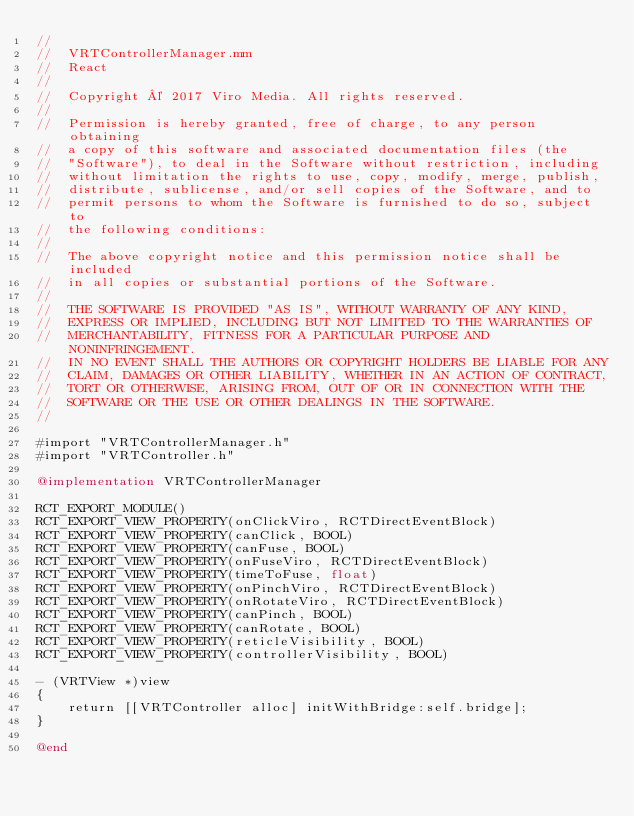<code> <loc_0><loc_0><loc_500><loc_500><_ObjectiveC_>//
//  VRTControllerManager.mm
//  React
//
//  Copyright © 2017 Viro Media. All rights reserved.
//
//  Permission is hereby granted, free of charge, to any person obtaining
//  a copy of this software and associated documentation files (the
//  "Software"), to deal in the Software without restriction, including
//  without limitation the rights to use, copy, modify, merge, publish,
//  distribute, sublicense, and/or sell copies of the Software, and to
//  permit persons to whom the Software is furnished to do so, subject to
//  the following conditions:
//
//  The above copyright notice and this permission notice shall be included
//  in all copies or substantial portions of the Software.
//
//  THE SOFTWARE IS PROVIDED "AS IS", WITHOUT WARRANTY OF ANY KIND,
//  EXPRESS OR IMPLIED, INCLUDING BUT NOT LIMITED TO THE WARRANTIES OF
//  MERCHANTABILITY, FITNESS FOR A PARTICULAR PURPOSE AND NONINFRINGEMENT.
//  IN NO EVENT SHALL THE AUTHORS OR COPYRIGHT HOLDERS BE LIABLE FOR ANY
//  CLAIM, DAMAGES OR OTHER LIABILITY, WHETHER IN AN ACTION OF CONTRACT,
//  TORT OR OTHERWISE, ARISING FROM, OUT OF OR IN CONNECTION WITH THE
//  SOFTWARE OR THE USE OR OTHER DEALINGS IN THE SOFTWARE.
//

#import "VRTControllerManager.h"
#import "VRTController.h"

@implementation VRTControllerManager

RCT_EXPORT_MODULE()
RCT_EXPORT_VIEW_PROPERTY(onClickViro, RCTDirectEventBlock)
RCT_EXPORT_VIEW_PROPERTY(canClick, BOOL)
RCT_EXPORT_VIEW_PROPERTY(canFuse, BOOL)
RCT_EXPORT_VIEW_PROPERTY(onFuseViro, RCTDirectEventBlock)
RCT_EXPORT_VIEW_PROPERTY(timeToFuse, float)
RCT_EXPORT_VIEW_PROPERTY(onPinchViro, RCTDirectEventBlock)
RCT_EXPORT_VIEW_PROPERTY(onRotateViro, RCTDirectEventBlock)
RCT_EXPORT_VIEW_PROPERTY(canPinch, BOOL)
RCT_EXPORT_VIEW_PROPERTY(canRotate, BOOL)
RCT_EXPORT_VIEW_PROPERTY(reticleVisibility, BOOL)
RCT_EXPORT_VIEW_PROPERTY(controllerVisibility, BOOL)

- (VRTView *)view
{
    return [[VRTController alloc] initWithBridge:self.bridge];
}

@end
</code> 